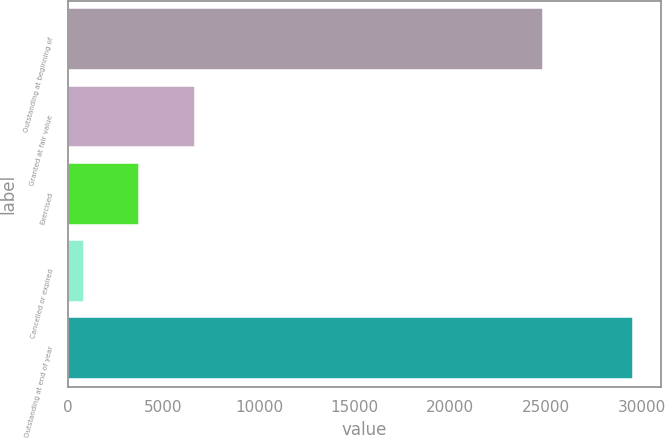Convert chart. <chart><loc_0><loc_0><loc_500><loc_500><bar_chart><fcel>Outstanding at beginning of<fcel>Granted at fair value<fcel>Exercised<fcel>Cancelled or expired<fcel>Outstanding at end of year<nl><fcel>24843.5<fcel>6651.2<fcel>3726.87<fcel>858.5<fcel>29542.2<nl></chart> 